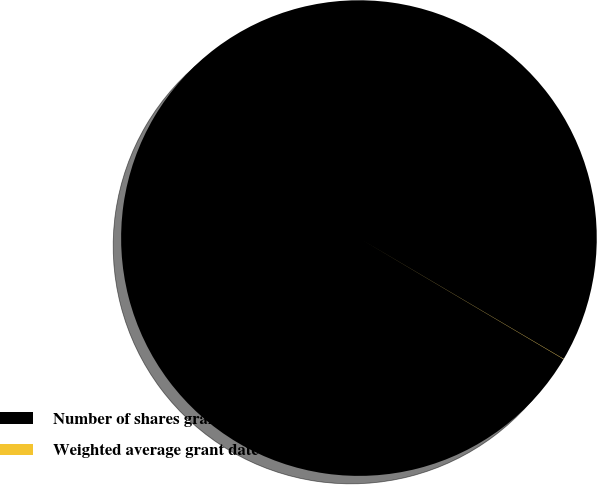Convert chart. <chart><loc_0><loc_0><loc_500><loc_500><pie_chart><fcel>Number of shares granted<fcel>Weighted average grant date<nl><fcel>99.98%<fcel>0.02%<nl></chart> 